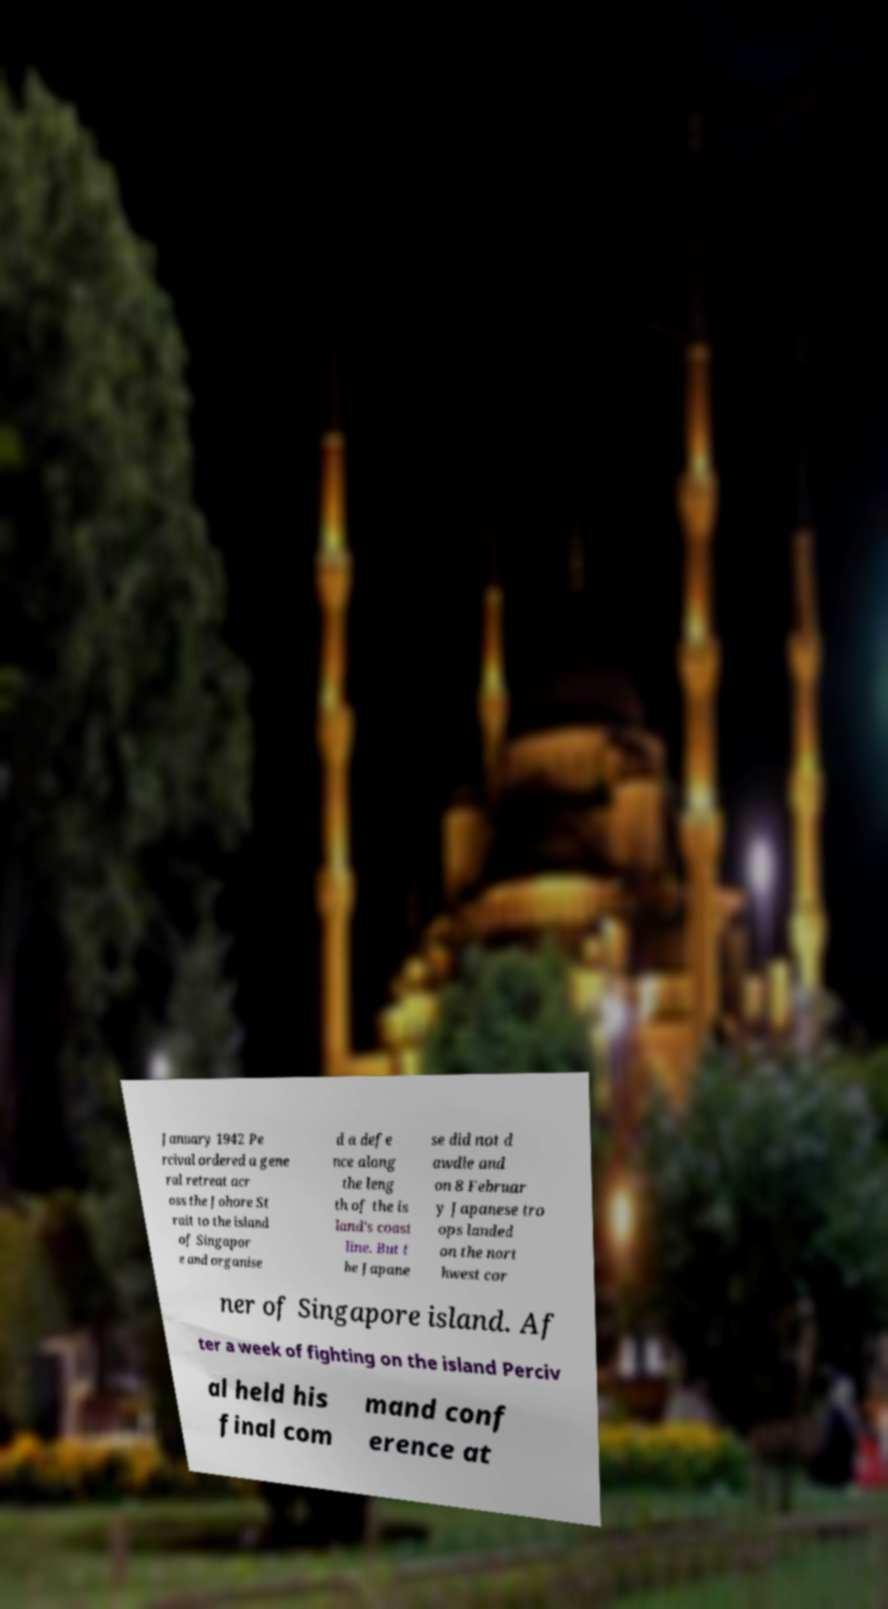For documentation purposes, I need the text within this image transcribed. Could you provide that? January 1942 Pe rcival ordered a gene ral retreat acr oss the Johore St rait to the island of Singapor e and organise d a defe nce along the leng th of the is land's coast line. But t he Japane se did not d awdle and on 8 Februar y Japanese tro ops landed on the nort hwest cor ner of Singapore island. Af ter a week of fighting on the island Perciv al held his final com mand conf erence at 